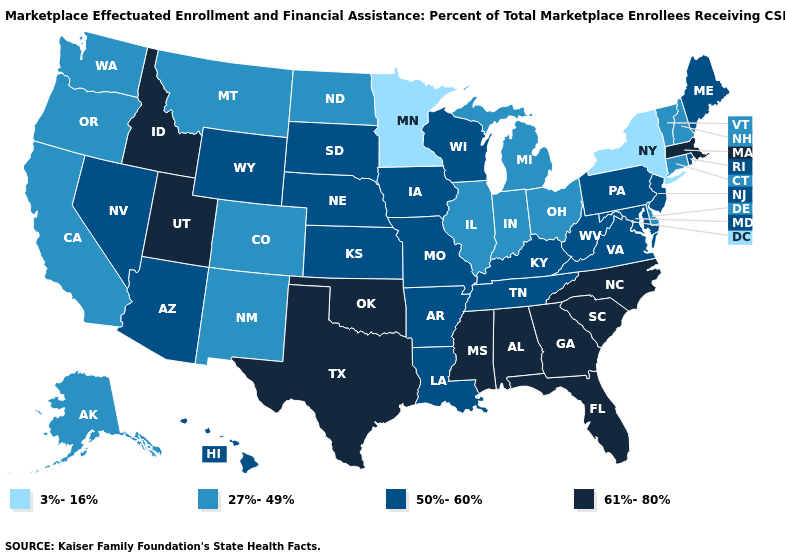What is the value of Illinois?
Keep it brief. 27%-49%. Is the legend a continuous bar?
Write a very short answer. No. Does Michigan have a lower value than Vermont?
Short answer required. No. Does New Mexico have the same value as Montana?
Short answer required. Yes. What is the highest value in the Northeast ?
Write a very short answer. 61%-80%. Does Wisconsin have a higher value than Washington?
Give a very brief answer. Yes. Which states have the lowest value in the USA?
Short answer required. Minnesota, New York. Among the states that border Michigan , does Ohio have the highest value?
Be succinct. No. Name the states that have a value in the range 50%-60%?
Quick response, please. Arizona, Arkansas, Hawaii, Iowa, Kansas, Kentucky, Louisiana, Maine, Maryland, Missouri, Nebraska, Nevada, New Jersey, Pennsylvania, Rhode Island, South Dakota, Tennessee, Virginia, West Virginia, Wisconsin, Wyoming. Name the states that have a value in the range 50%-60%?
Keep it brief. Arizona, Arkansas, Hawaii, Iowa, Kansas, Kentucky, Louisiana, Maine, Maryland, Missouri, Nebraska, Nevada, New Jersey, Pennsylvania, Rhode Island, South Dakota, Tennessee, Virginia, West Virginia, Wisconsin, Wyoming. Does Massachusetts have the highest value in the Northeast?
Concise answer only. Yes. What is the value of Idaho?
Quick response, please. 61%-80%. What is the lowest value in the USA?
Write a very short answer. 3%-16%. What is the highest value in the Northeast ?
Give a very brief answer. 61%-80%. What is the value of Idaho?
Be succinct. 61%-80%. 